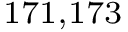Convert formula to latex. <formula><loc_0><loc_0><loc_500><loc_500>^ { 1 7 1 , 1 7 3 }</formula> 